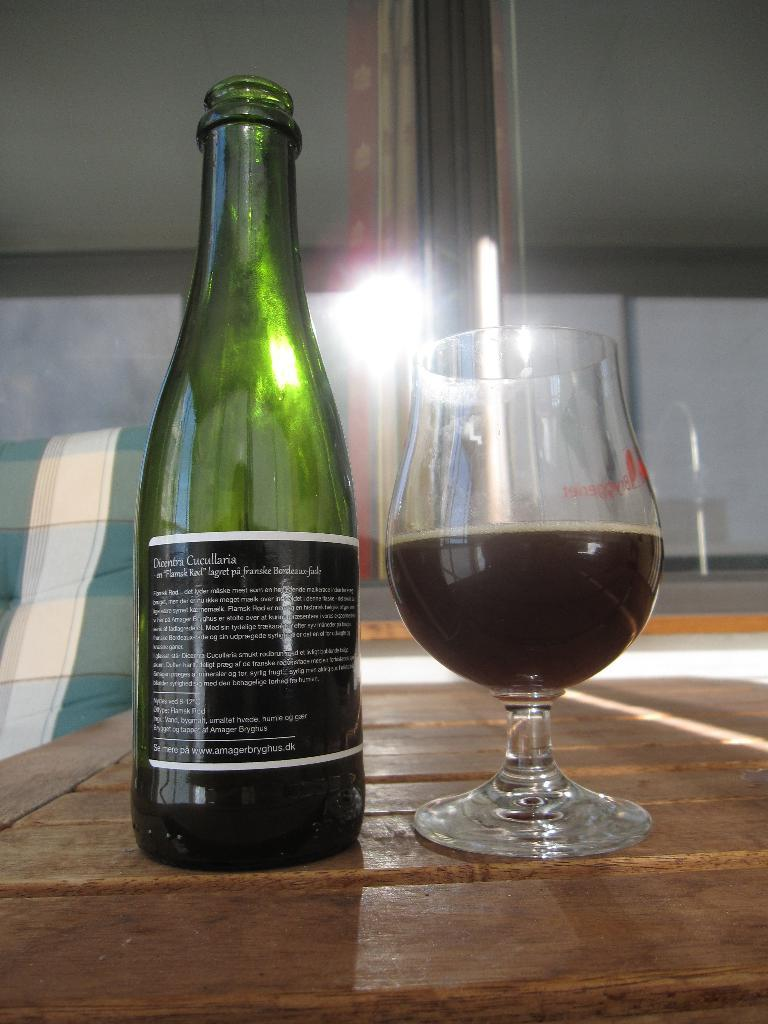What type of beverage container is present in the image? There is a wine bottle in the image. What type of drinking vessel is also present in the image? There is a wine glass in the image. Where are the wine bottle and the wine glass located? Both the wine bottle and the wine glass are on a table. What type of game is being played with the wine bottle and the wine glass in the image? There is no game being played with the wine bottle and the wine glass in the image; they are simply on a table. What type of paint is being used to decorate the wine bottle and the wine glass in the image? There is no paint or decoration visible on the wine bottle and the wine glass in the image; they are plain. 